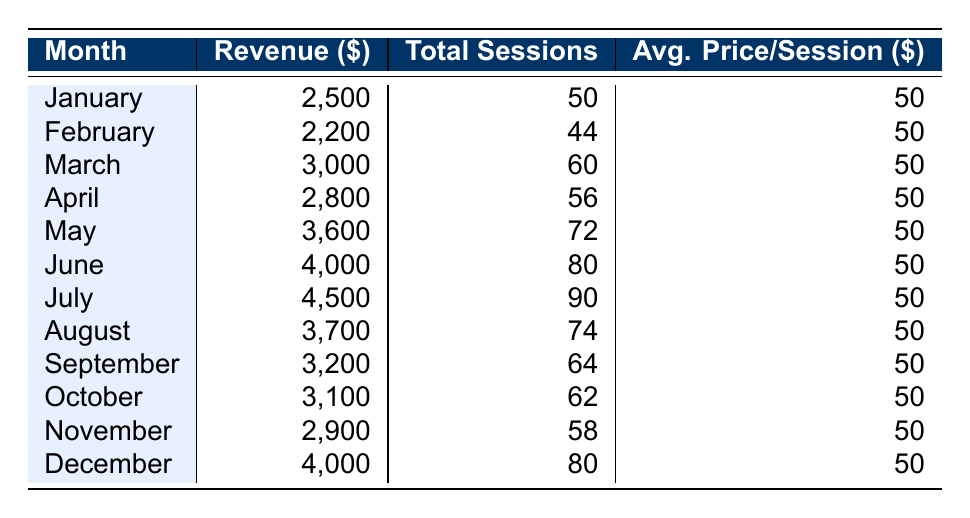What was the revenue in July? Looking at the table, the revenue listed for July is 4,500.
Answer: 4,500 In which month did the business generate the least revenue? By comparing all months in the table, February has the least revenue listed at 2,200.
Answer: February What is the total revenue for the first half of the year (January to June)? To find this, we sum the revenue for each month from January (2,500) to June (4,000): 2,500 + 2,200 + 3,000 + 2,800 + 3,600 + 4,000 = 18,100.
Answer: 18,100 Was the average price per session consistent throughout the year? The table shows that the average price per session is consistently recorded as 50 for every month.
Answer: Yes How much more revenue was generated in December compared to February? We find the revenue for December (4,000) and subtract the revenue for February (2,200): 4,000 - 2,200 = 1,800.
Answer: 1,800 What is the total number of sessions conducted over the entire year? Adding up the total sessions: 50 + 44 + 60 + 56 + 72 + 80 + 90 + 74 + 64 + 62 + 58 + 80 =  80.
Answer: 80 In which month was the revenue significantly higher than average? The annual average revenue can be calculated by summing all monthly revenues (32,600) and dividing by 12, resulting in approximately 2,716.67. July, with 4,500, is much higher than this average.
Answer: July How does the revenue in October compare to the revenue in March? October's revenue is 3,100, while March's revenue is 3,000. Comparing these, October's revenue is higher by 100.
Answer: October's revenue is higher by 100 What was the average revenue per session across all months? To find this, we can calculate the total revenue (32,600) and divide it by the total sessions (704) across the year: 32,600 / 704 ≈ 46.25.
Answer: 46.25 